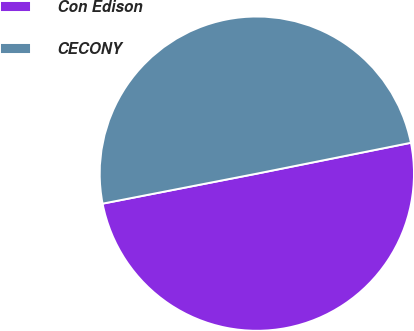Convert chart. <chart><loc_0><loc_0><loc_500><loc_500><pie_chart><fcel>Con Edison<fcel>CECONY<nl><fcel>50.09%<fcel>49.91%<nl></chart> 